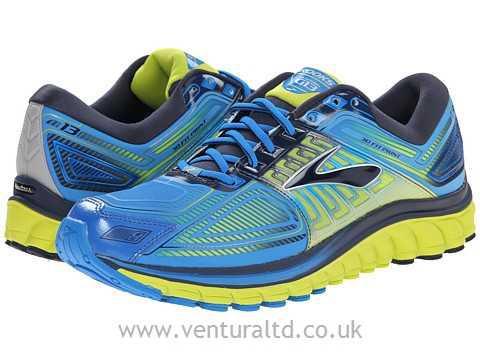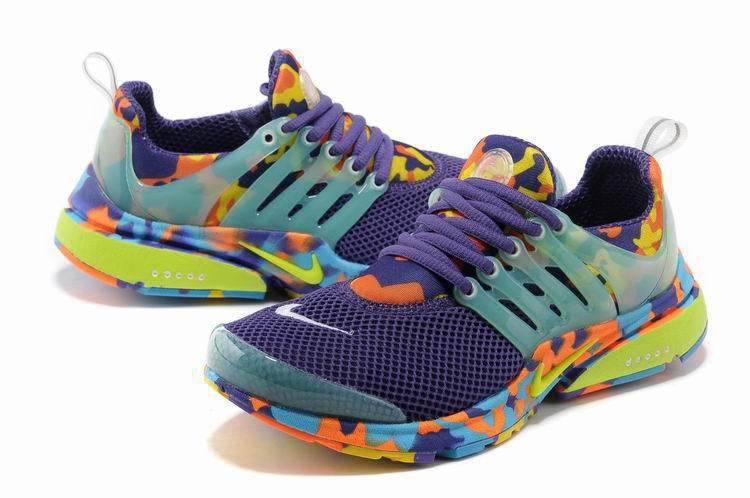The first image is the image on the left, the second image is the image on the right. Considering the images on both sides, is "At least one image shows exactly one pair of shoes." valid? Answer yes or no. Yes. The first image is the image on the left, the second image is the image on the right. Evaluate the accuracy of this statement regarding the images: "1 of the images has 1 shoe facing right in the foreground.". Is it true? Answer yes or no. No. 